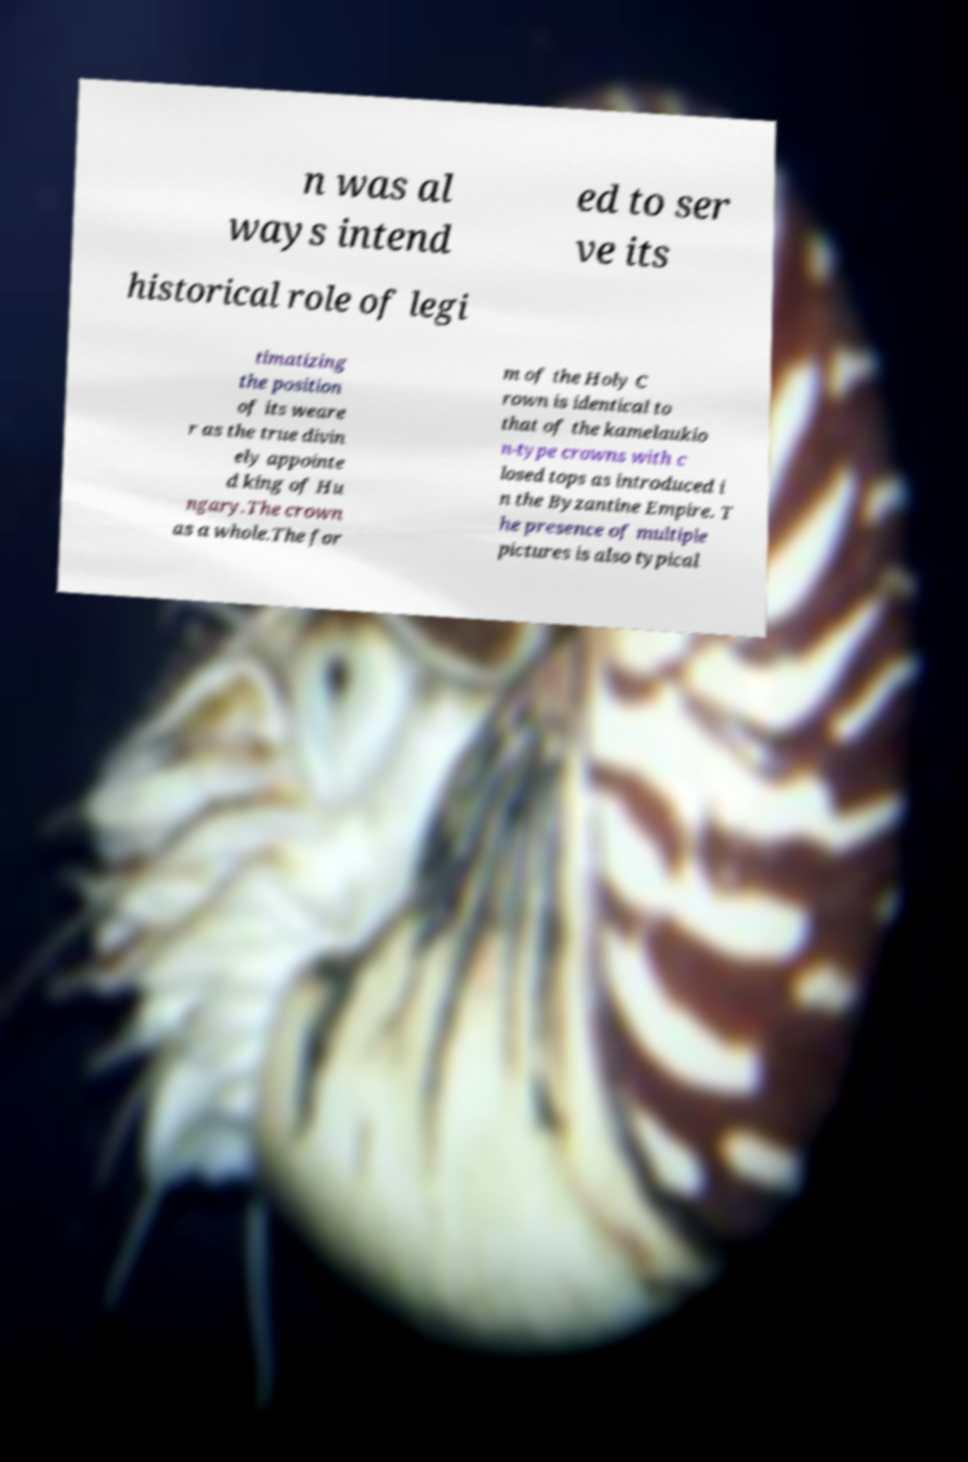I need the written content from this picture converted into text. Can you do that? n was al ways intend ed to ser ve its historical role of legi timatizing the position of its weare r as the true divin ely appointe d king of Hu ngary.The crown as a whole.The for m of the Holy C rown is identical to that of the kamelaukio n-type crowns with c losed tops as introduced i n the Byzantine Empire. T he presence of multiple pictures is also typical 